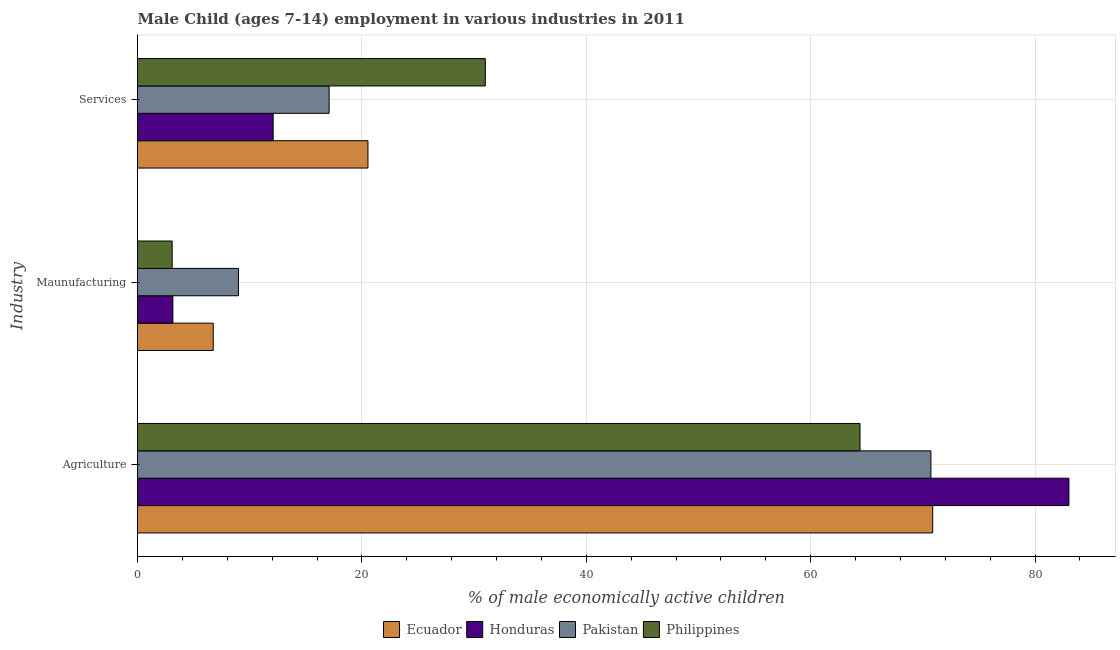How many groups of bars are there?
Provide a short and direct response. 3. Are the number of bars on each tick of the Y-axis equal?
Provide a succinct answer. Yes. How many bars are there on the 2nd tick from the top?
Offer a terse response. 4. How many bars are there on the 2nd tick from the bottom?
Keep it short and to the point. 4. What is the label of the 1st group of bars from the top?
Make the answer very short. Services. Across all countries, what is the maximum percentage of economically active children in manufacturing?
Keep it short and to the point. 9. Across all countries, what is the minimum percentage of economically active children in services?
Your answer should be very brief. 12.09. In which country was the percentage of economically active children in agriculture maximum?
Your answer should be very brief. Honduras. In which country was the percentage of economically active children in manufacturing minimum?
Provide a short and direct response. Philippines. What is the total percentage of economically active children in services in the graph?
Your answer should be compact. 80.71. What is the difference between the percentage of economically active children in manufacturing in Honduras and that in Ecuador?
Provide a succinct answer. -3.6. What is the difference between the percentage of economically active children in agriculture in Pakistan and the percentage of economically active children in manufacturing in Philippines?
Offer a very short reply. 67.63. What is the average percentage of economically active children in manufacturing per country?
Provide a succinct answer. 5.5. What is the difference between the percentage of economically active children in agriculture and percentage of economically active children in manufacturing in Pakistan?
Ensure brevity in your answer.  61.72. What is the ratio of the percentage of economically active children in services in Philippines to that in Honduras?
Make the answer very short. 2.56. Is the difference between the percentage of economically active children in manufacturing in Philippines and Honduras greater than the difference between the percentage of economically active children in services in Philippines and Honduras?
Make the answer very short. No. What is the difference between the highest and the second highest percentage of economically active children in services?
Offer a terse response. 10.46. What is the difference between the highest and the lowest percentage of economically active children in manufacturing?
Provide a short and direct response. 5.91. In how many countries, is the percentage of economically active children in agriculture greater than the average percentage of economically active children in agriculture taken over all countries?
Your response must be concise. 1. Is the sum of the percentage of economically active children in manufacturing in Pakistan and Honduras greater than the maximum percentage of economically active children in agriculture across all countries?
Offer a very short reply. No. Is it the case that in every country, the sum of the percentage of economically active children in agriculture and percentage of economically active children in manufacturing is greater than the percentage of economically active children in services?
Offer a terse response. Yes. How many bars are there?
Provide a short and direct response. 12. Are all the bars in the graph horizontal?
Your answer should be very brief. Yes. How many countries are there in the graph?
Ensure brevity in your answer.  4. Are the values on the major ticks of X-axis written in scientific E-notation?
Give a very brief answer. No. Does the graph contain grids?
Make the answer very short. Yes. How many legend labels are there?
Provide a succinct answer. 4. What is the title of the graph?
Give a very brief answer. Male Child (ages 7-14) employment in various industries in 2011. Does "Central African Republic" appear as one of the legend labels in the graph?
Make the answer very short. No. What is the label or title of the X-axis?
Ensure brevity in your answer.  % of male economically active children. What is the label or title of the Y-axis?
Your answer should be compact. Industry. What is the % of male economically active children of Ecuador in Agriculture?
Make the answer very short. 70.88. What is the % of male economically active children in Honduras in Agriculture?
Your response must be concise. 83.02. What is the % of male economically active children in Pakistan in Agriculture?
Offer a very short reply. 70.72. What is the % of male economically active children in Philippines in Agriculture?
Make the answer very short. 64.4. What is the % of male economically active children in Ecuador in Maunufacturing?
Offer a very short reply. 6.75. What is the % of male economically active children of Honduras in Maunufacturing?
Make the answer very short. 3.15. What is the % of male economically active children in Pakistan in Maunufacturing?
Offer a very short reply. 9. What is the % of male economically active children of Philippines in Maunufacturing?
Provide a succinct answer. 3.09. What is the % of male economically active children in Ecuador in Services?
Provide a succinct answer. 20.54. What is the % of male economically active children in Honduras in Services?
Provide a succinct answer. 12.09. What is the % of male economically active children of Pakistan in Services?
Give a very brief answer. 17.08. What is the % of male economically active children of Philippines in Services?
Your answer should be compact. 31. Across all Industry, what is the maximum % of male economically active children of Ecuador?
Ensure brevity in your answer.  70.88. Across all Industry, what is the maximum % of male economically active children in Honduras?
Offer a very short reply. 83.02. Across all Industry, what is the maximum % of male economically active children of Pakistan?
Your answer should be very brief. 70.72. Across all Industry, what is the maximum % of male economically active children of Philippines?
Offer a terse response. 64.4. Across all Industry, what is the minimum % of male economically active children in Ecuador?
Provide a short and direct response. 6.75. Across all Industry, what is the minimum % of male economically active children in Honduras?
Make the answer very short. 3.15. Across all Industry, what is the minimum % of male economically active children in Philippines?
Your response must be concise. 3.09. What is the total % of male economically active children of Ecuador in the graph?
Your answer should be very brief. 98.17. What is the total % of male economically active children in Honduras in the graph?
Provide a short and direct response. 98.26. What is the total % of male economically active children in Pakistan in the graph?
Offer a very short reply. 96.8. What is the total % of male economically active children of Philippines in the graph?
Provide a succinct answer. 98.49. What is the difference between the % of male economically active children in Ecuador in Agriculture and that in Maunufacturing?
Offer a terse response. 64.13. What is the difference between the % of male economically active children in Honduras in Agriculture and that in Maunufacturing?
Your answer should be very brief. 79.87. What is the difference between the % of male economically active children in Pakistan in Agriculture and that in Maunufacturing?
Make the answer very short. 61.72. What is the difference between the % of male economically active children in Philippines in Agriculture and that in Maunufacturing?
Provide a succinct answer. 61.31. What is the difference between the % of male economically active children in Ecuador in Agriculture and that in Services?
Your answer should be very brief. 50.34. What is the difference between the % of male economically active children of Honduras in Agriculture and that in Services?
Provide a short and direct response. 70.93. What is the difference between the % of male economically active children of Pakistan in Agriculture and that in Services?
Your answer should be compact. 53.64. What is the difference between the % of male economically active children of Philippines in Agriculture and that in Services?
Your answer should be very brief. 33.4. What is the difference between the % of male economically active children in Ecuador in Maunufacturing and that in Services?
Offer a very short reply. -13.79. What is the difference between the % of male economically active children in Honduras in Maunufacturing and that in Services?
Provide a short and direct response. -8.94. What is the difference between the % of male economically active children of Pakistan in Maunufacturing and that in Services?
Provide a succinct answer. -8.08. What is the difference between the % of male economically active children of Philippines in Maunufacturing and that in Services?
Your answer should be very brief. -27.91. What is the difference between the % of male economically active children of Ecuador in Agriculture and the % of male economically active children of Honduras in Maunufacturing?
Your response must be concise. 67.73. What is the difference between the % of male economically active children of Ecuador in Agriculture and the % of male economically active children of Pakistan in Maunufacturing?
Ensure brevity in your answer.  61.88. What is the difference between the % of male economically active children of Ecuador in Agriculture and the % of male economically active children of Philippines in Maunufacturing?
Ensure brevity in your answer.  67.79. What is the difference between the % of male economically active children in Honduras in Agriculture and the % of male economically active children in Pakistan in Maunufacturing?
Your answer should be compact. 74.02. What is the difference between the % of male economically active children of Honduras in Agriculture and the % of male economically active children of Philippines in Maunufacturing?
Give a very brief answer. 79.93. What is the difference between the % of male economically active children in Pakistan in Agriculture and the % of male economically active children in Philippines in Maunufacturing?
Offer a very short reply. 67.63. What is the difference between the % of male economically active children of Ecuador in Agriculture and the % of male economically active children of Honduras in Services?
Provide a succinct answer. 58.79. What is the difference between the % of male economically active children of Ecuador in Agriculture and the % of male economically active children of Pakistan in Services?
Keep it short and to the point. 53.8. What is the difference between the % of male economically active children in Ecuador in Agriculture and the % of male economically active children in Philippines in Services?
Give a very brief answer. 39.88. What is the difference between the % of male economically active children of Honduras in Agriculture and the % of male economically active children of Pakistan in Services?
Keep it short and to the point. 65.94. What is the difference between the % of male economically active children in Honduras in Agriculture and the % of male economically active children in Philippines in Services?
Ensure brevity in your answer.  52.02. What is the difference between the % of male economically active children in Pakistan in Agriculture and the % of male economically active children in Philippines in Services?
Offer a very short reply. 39.72. What is the difference between the % of male economically active children of Ecuador in Maunufacturing and the % of male economically active children of Honduras in Services?
Give a very brief answer. -5.34. What is the difference between the % of male economically active children in Ecuador in Maunufacturing and the % of male economically active children in Pakistan in Services?
Make the answer very short. -10.33. What is the difference between the % of male economically active children in Ecuador in Maunufacturing and the % of male economically active children in Philippines in Services?
Make the answer very short. -24.25. What is the difference between the % of male economically active children in Honduras in Maunufacturing and the % of male economically active children in Pakistan in Services?
Provide a short and direct response. -13.93. What is the difference between the % of male economically active children of Honduras in Maunufacturing and the % of male economically active children of Philippines in Services?
Offer a terse response. -27.85. What is the difference between the % of male economically active children in Pakistan in Maunufacturing and the % of male economically active children in Philippines in Services?
Offer a very short reply. -22. What is the average % of male economically active children in Ecuador per Industry?
Offer a terse response. 32.72. What is the average % of male economically active children of Honduras per Industry?
Provide a succinct answer. 32.75. What is the average % of male economically active children in Pakistan per Industry?
Give a very brief answer. 32.27. What is the average % of male economically active children of Philippines per Industry?
Provide a short and direct response. 32.83. What is the difference between the % of male economically active children in Ecuador and % of male economically active children in Honduras in Agriculture?
Provide a short and direct response. -12.14. What is the difference between the % of male economically active children of Ecuador and % of male economically active children of Pakistan in Agriculture?
Your answer should be compact. 0.16. What is the difference between the % of male economically active children of Ecuador and % of male economically active children of Philippines in Agriculture?
Keep it short and to the point. 6.48. What is the difference between the % of male economically active children in Honduras and % of male economically active children in Philippines in Agriculture?
Offer a very short reply. 18.62. What is the difference between the % of male economically active children of Pakistan and % of male economically active children of Philippines in Agriculture?
Offer a terse response. 6.32. What is the difference between the % of male economically active children in Ecuador and % of male economically active children in Honduras in Maunufacturing?
Offer a terse response. 3.6. What is the difference between the % of male economically active children of Ecuador and % of male economically active children of Pakistan in Maunufacturing?
Your answer should be compact. -2.25. What is the difference between the % of male economically active children in Ecuador and % of male economically active children in Philippines in Maunufacturing?
Your answer should be compact. 3.66. What is the difference between the % of male economically active children of Honduras and % of male economically active children of Pakistan in Maunufacturing?
Your response must be concise. -5.85. What is the difference between the % of male economically active children in Pakistan and % of male economically active children in Philippines in Maunufacturing?
Keep it short and to the point. 5.91. What is the difference between the % of male economically active children of Ecuador and % of male economically active children of Honduras in Services?
Keep it short and to the point. 8.45. What is the difference between the % of male economically active children in Ecuador and % of male economically active children in Pakistan in Services?
Your answer should be very brief. 3.46. What is the difference between the % of male economically active children in Ecuador and % of male economically active children in Philippines in Services?
Ensure brevity in your answer.  -10.46. What is the difference between the % of male economically active children in Honduras and % of male economically active children in Pakistan in Services?
Provide a succinct answer. -4.99. What is the difference between the % of male economically active children in Honduras and % of male economically active children in Philippines in Services?
Offer a very short reply. -18.91. What is the difference between the % of male economically active children in Pakistan and % of male economically active children in Philippines in Services?
Ensure brevity in your answer.  -13.92. What is the ratio of the % of male economically active children of Ecuador in Agriculture to that in Maunufacturing?
Ensure brevity in your answer.  10.5. What is the ratio of the % of male economically active children of Honduras in Agriculture to that in Maunufacturing?
Give a very brief answer. 26.36. What is the ratio of the % of male economically active children of Pakistan in Agriculture to that in Maunufacturing?
Provide a succinct answer. 7.86. What is the ratio of the % of male economically active children in Philippines in Agriculture to that in Maunufacturing?
Make the answer very short. 20.84. What is the ratio of the % of male economically active children of Ecuador in Agriculture to that in Services?
Offer a very short reply. 3.45. What is the ratio of the % of male economically active children in Honduras in Agriculture to that in Services?
Make the answer very short. 6.87. What is the ratio of the % of male economically active children in Pakistan in Agriculture to that in Services?
Ensure brevity in your answer.  4.14. What is the ratio of the % of male economically active children in Philippines in Agriculture to that in Services?
Provide a short and direct response. 2.08. What is the ratio of the % of male economically active children in Ecuador in Maunufacturing to that in Services?
Make the answer very short. 0.33. What is the ratio of the % of male economically active children in Honduras in Maunufacturing to that in Services?
Keep it short and to the point. 0.26. What is the ratio of the % of male economically active children in Pakistan in Maunufacturing to that in Services?
Keep it short and to the point. 0.53. What is the ratio of the % of male economically active children of Philippines in Maunufacturing to that in Services?
Offer a terse response. 0.1. What is the difference between the highest and the second highest % of male economically active children in Ecuador?
Offer a very short reply. 50.34. What is the difference between the highest and the second highest % of male economically active children in Honduras?
Your answer should be very brief. 70.93. What is the difference between the highest and the second highest % of male economically active children of Pakistan?
Ensure brevity in your answer.  53.64. What is the difference between the highest and the second highest % of male economically active children of Philippines?
Your response must be concise. 33.4. What is the difference between the highest and the lowest % of male economically active children in Ecuador?
Offer a terse response. 64.13. What is the difference between the highest and the lowest % of male economically active children of Honduras?
Ensure brevity in your answer.  79.87. What is the difference between the highest and the lowest % of male economically active children of Pakistan?
Keep it short and to the point. 61.72. What is the difference between the highest and the lowest % of male economically active children in Philippines?
Make the answer very short. 61.31. 